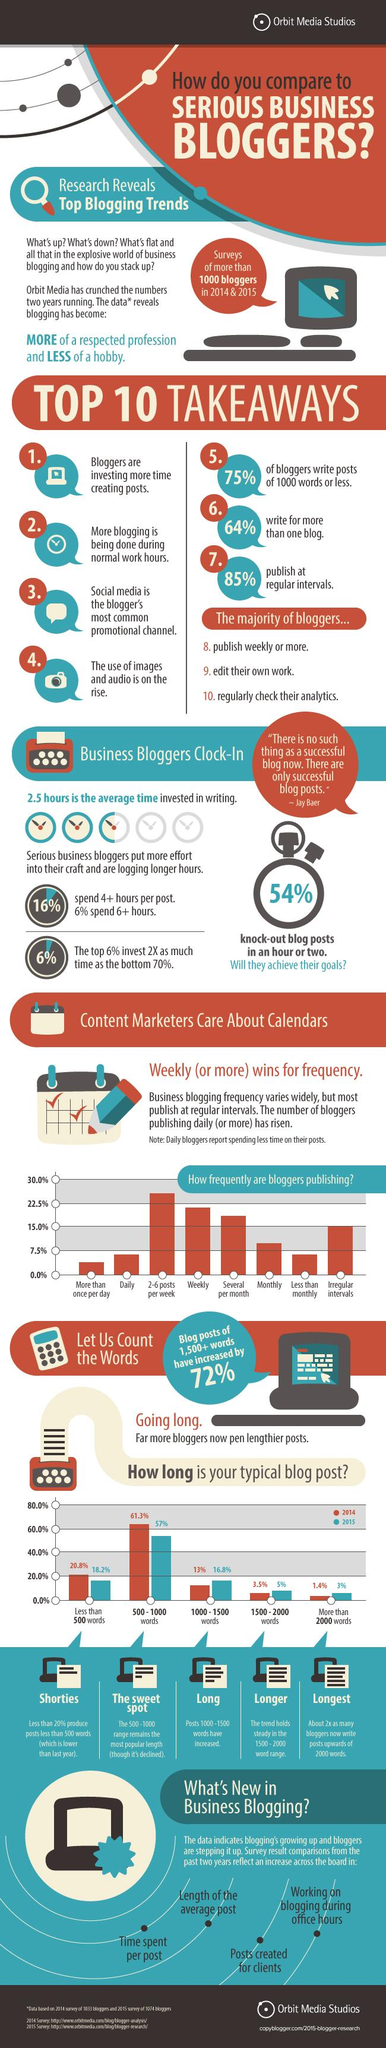Highlight a few significant elements in this photo. In 2015, approximately 57% of blog posts had a word count between 500 and 1000. A survey found that 15.0% of people post at irregular intervals. 